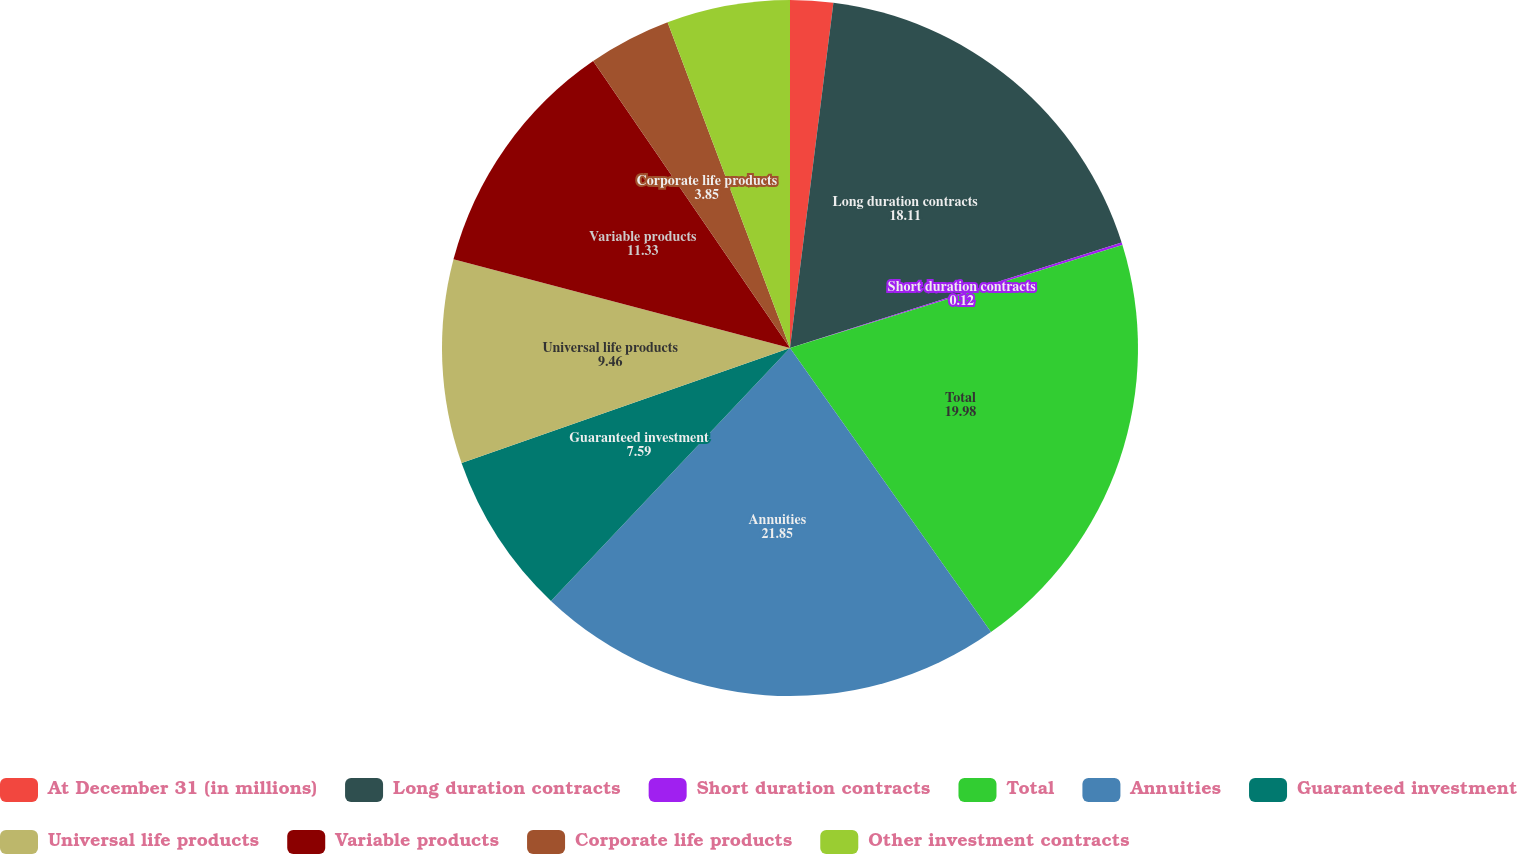<chart> <loc_0><loc_0><loc_500><loc_500><pie_chart><fcel>At December 31 (in millions)<fcel>Long duration contracts<fcel>Short duration contracts<fcel>Total<fcel>Annuities<fcel>Guaranteed investment<fcel>Universal life products<fcel>Variable products<fcel>Corporate life products<fcel>Other investment contracts<nl><fcel>1.99%<fcel>18.11%<fcel>0.12%<fcel>19.98%<fcel>21.85%<fcel>7.59%<fcel>9.46%<fcel>11.33%<fcel>3.85%<fcel>5.72%<nl></chart> 